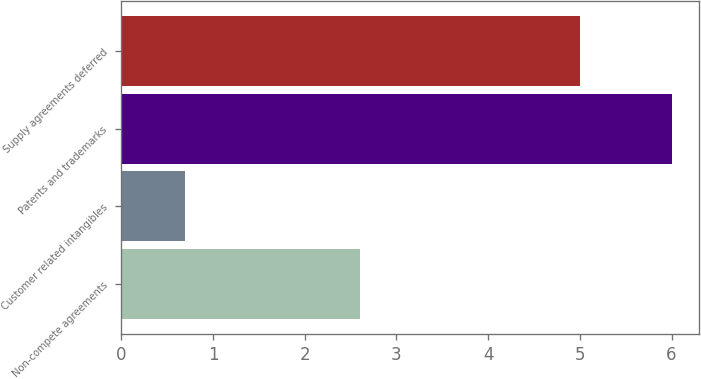Convert chart to OTSL. <chart><loc_0><loc_0><loc_500><loc_500><bar_chart><fcel>Non-compete agreements<fcel>Customer related intangibles<fcel>Patents and trademarks<fcel>Supply agreements deferred<nl><fcel>2.6<fcel>0.7<fcel>6<fcel>5<nl></chart> 